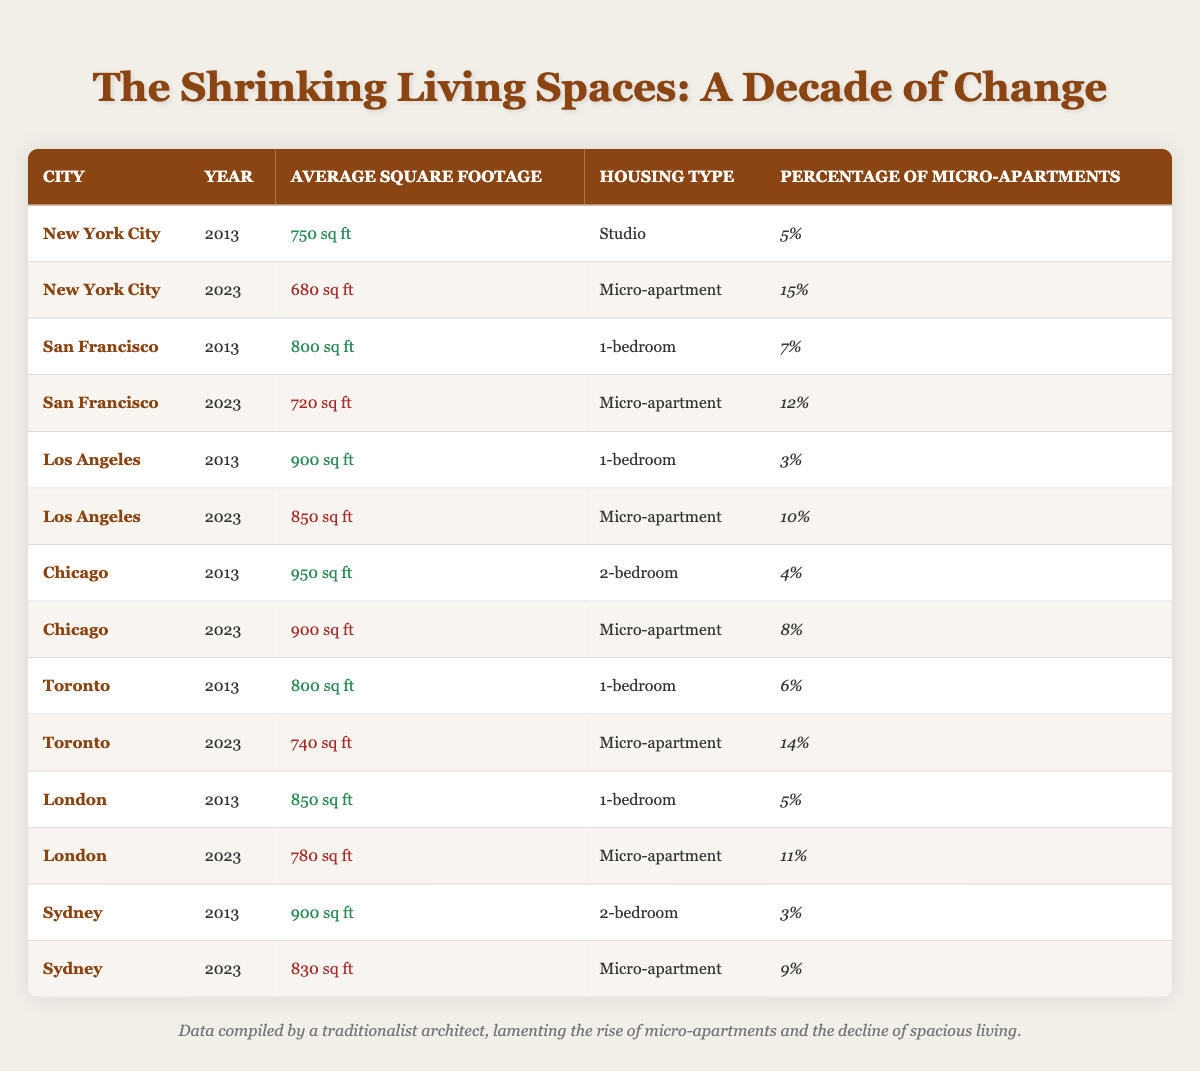What was the average square footage of micro-apartments in New York City in 2023? The table shows that in New York City in 2023, the average square footage of micro-apartments is listed as 680 sq ft.
Answer: 680 sq ft What percentage of the housing in San Francisco were micro-apartments in 2013? According to the table, in 2013, the percentage of micro-apartments in San Francisco was 7%.
Answer: 7% Did the average square footage of housing in Chicago decrease from 2013 to 2023? Comparing the values from the table, in 2013, the average square footage was 950 sq ft, and in 2023 it was 900 sq ft, indicating a decrease of 50 sq ft.
Answer: Yes What is the total percentage of micro-apartments in Toronto for the years 2013 and 2023 combined? From the table, in Toronto, the percentage of micro-apartments was 6% in 2013 and 14% in 2023. Adding these values gives 6% + 14% = 20%.
Answer: 20% Was the average square footage of micro-apartments in Sydney higher in 2023 than in Los Angeles in the same year? In Sydney for 2023, the average square footage of micro-apartments was 830 sq ft, while in Los Angeles it was 850 sq ft. Since 830 is less than 850, the average in Sydney is not higher.
Answer: No What is the change in average square footage of micro-apartments in London from 2013 to 2023? In London, the average square footage of micro-apartments was 850 sq ft in 2013 and decreased to 780 sq ft in 2023. The change can be calculated as 850 - 780 = 70 sq ft, showing a decrease.
Answer: Decrease of 70 sq ft What is the average square footage of 1-bedroom apartments in San Francisco and Toronto in 2013? Referring to the table, the average square footage for 1-bedroom apartments is 800 sq ft in San Francisco and 800 sq ft in Toronto. Adding them gives 800 + 800 = 1600 sq ft, and dividing by 2 for the average results in 800 sq ft.
Answer: 800 sq ft How many cities had an increase in the percentage of micro-apartments from 2013 to 2023? By checking the data, New York City (5% to 15%), San Francisco (7% to 12%), Chicago (4% to 8%), Toronto (6% to 14%), and London (5% to 11%) all showed increases, totaling 5 cities with increases.
Answer: 5 cities Which city had the highest average square footage for micro-apartments in 2023? The table lists the average square footages of micro-apartments for 2023: New York City has 680 sq ft, San Francisco has 720 sq ft, Los Angeles has 850 sq ft, Chicago has 900 sq ft, Toronto has 740 sq ft, London has 780 sq ft, and Sydney has 830 sq ft. The highest is in Los Angeles at 850 sq ft.
Answer: Los Angeles 